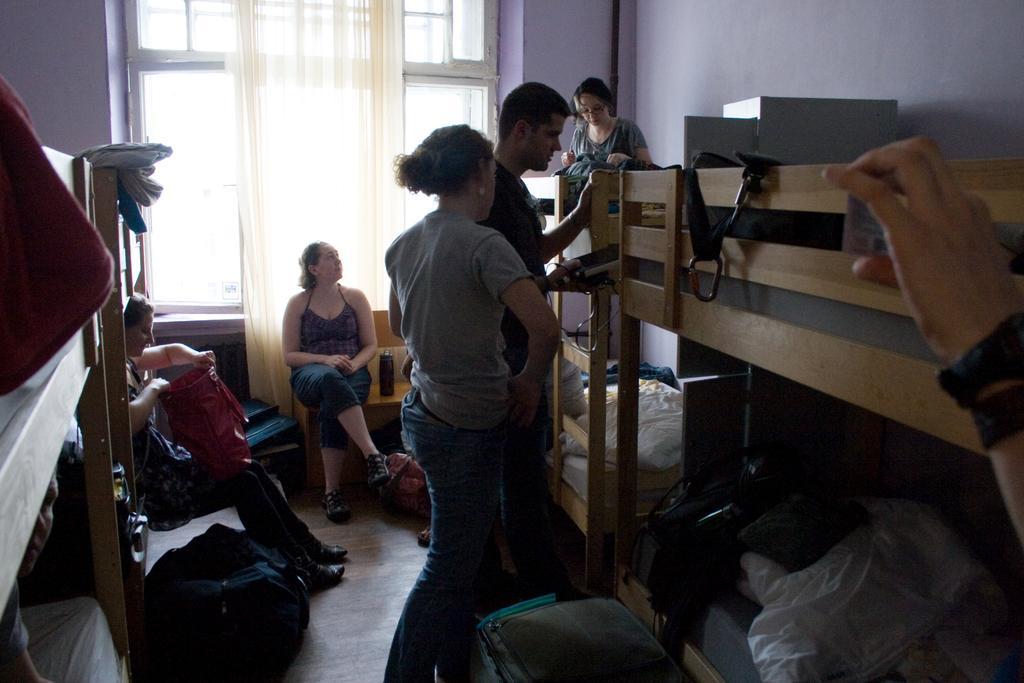Could you give a brief overview of what you see in this image? In this image we can see a group of people are sitting, and some are standing, there is a wooden cot, and there are some objects on it, there is a window, there is a curtain, there is a wall. 